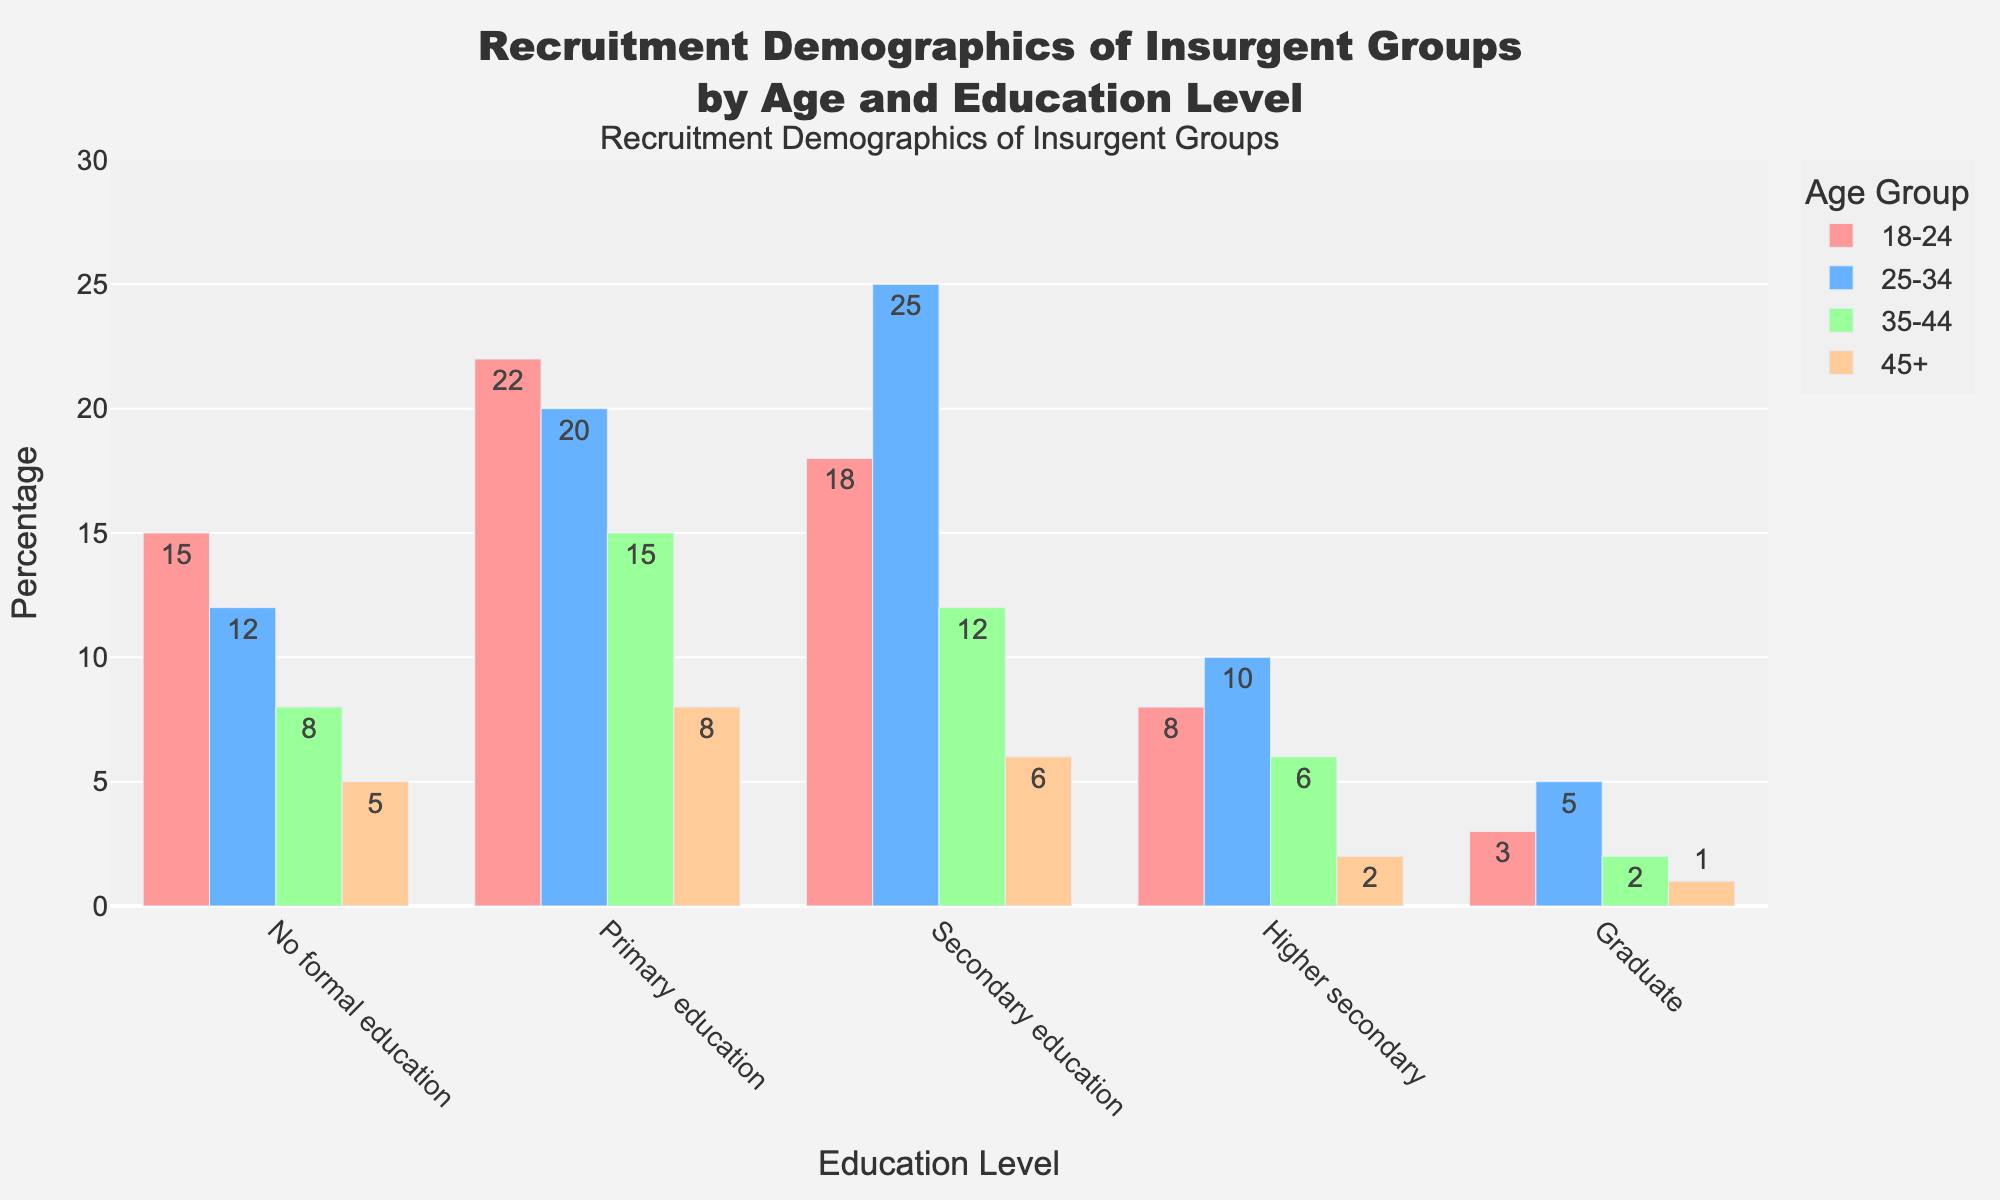Which education level has the highest recruitment percentage for the 18-24 age group? Look at the bars representing the 18-24 age group. The tallest bar corresponds to "Primary education" at 22%.
Answer: Primary education Which age group has the lowest percentage of recruits with a graduate education? Refer to all age groups and identify the one with the smallest bar for "Graduate" education. The 45+ age group has the shortest bar, at 1%.
Answer: 45+ What is the total percentage of recruits aged 25-34 with secondary and higher secondary education combined? Sum the percentages for "Secondary education" (25%) and "Higher secondary" (10%) in the 25-34 age group. The calculation is 25 + 10 = 35.
Answer: 35% How does the recruitment percentage of those with no formal education compare between the 35-44 and 45+ age groups? Compare the bars for "No formal education" between the 35-44 age group (8%) and the 45+ age group (5%). 8% is greater than 5%.
Answer: The 35-44 group has a higher percentage Which age group has the most evenly distributed recruitment percentages across all education levels? Examine the bars for all education levels within each age group. The 35-44 age group has smaller differences between its bars compared to other age groups.
Answer: 35-44 What is the difference in the recruitment percentage of recruits with primary education between the 18-24 and 25-34 age groups? Subtract the percentage for the 18-24 age group (22%) from the 25-34 age group (20%). The difference is 22 - 20 = 2.
Answer: 2% Which education level shows a decreasing trend in recruitment percentage as age increases? Look for an education level where bars progressively decrease from left to right. "No formal education" shows this trend with 15%, 12%, 8%, and 5% from youngest to oldest age groups.
Answer: No formal education What is the combined recruitment percentage for individuals aged 18-24 with any level of secondary education (secondary and higher secondary)? Add the percentages for "Secondary education" (18%) and "Higher secondary" (8%) in the 18-24 age group. The total is 18 + 8 = 26.
Answer: 26% Which age group contributes the highest recruitment percentage for secondary education? Referring to the bars representing "Secondary education", the 25-34 age group has the highest at 25%.
Answer: 25-34 How much higher is the recruitment percentage for primary education in the 18-24 age group compared to the 35-44 age group? Subtract the percentage for the 35-44 age group (15%) from the 18-24 age group (22%). The result is 22 - 15 = 7.
Answer: 7% 